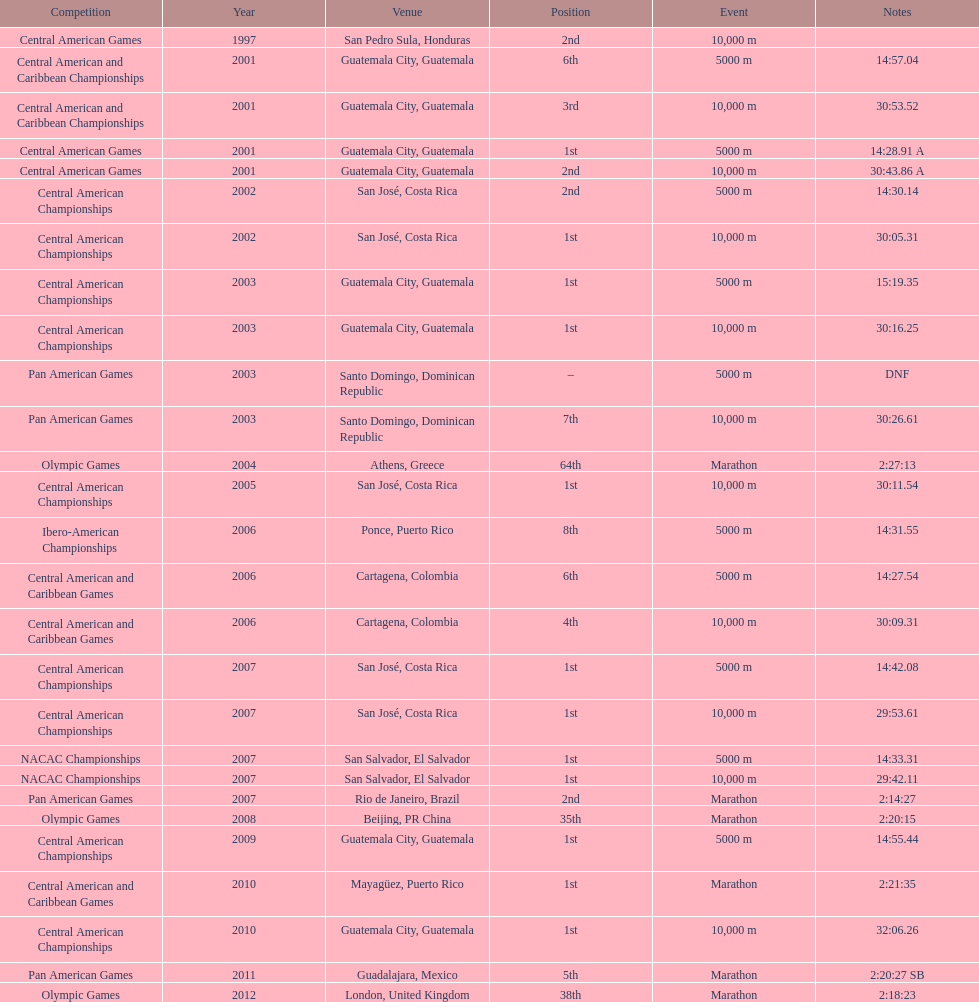How many times has the position of 1st been achieved? 12. 